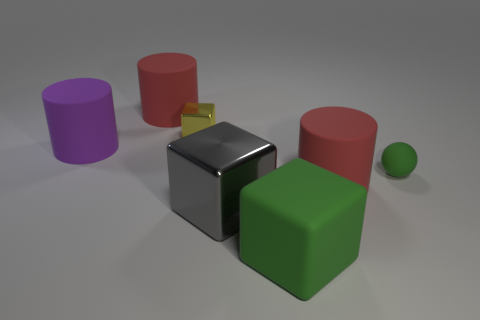Subtract all spheres. How many objects are left? 6 Add 1 large matte blocks. How many large matte blocks are left? 2 Add 5 yellow metallic blocks. How many yellow metallic blocks exist? 6 Add 1 tiny green balls. How many objects exist? 8 Subtract all purple cylinders. How many cylinders are left? 2 Subtract all metal cubes. How many cubes are left? 1 Subtract 0 gray balls. How many objects are left? 7 Subtract 1 spheres. How many spheres are left? 0 Subtract all yellow blocks. Subtract all red cylinders. How many blocks are left? 2 Subtract all cyan balls. How many green blocks are left? 1 